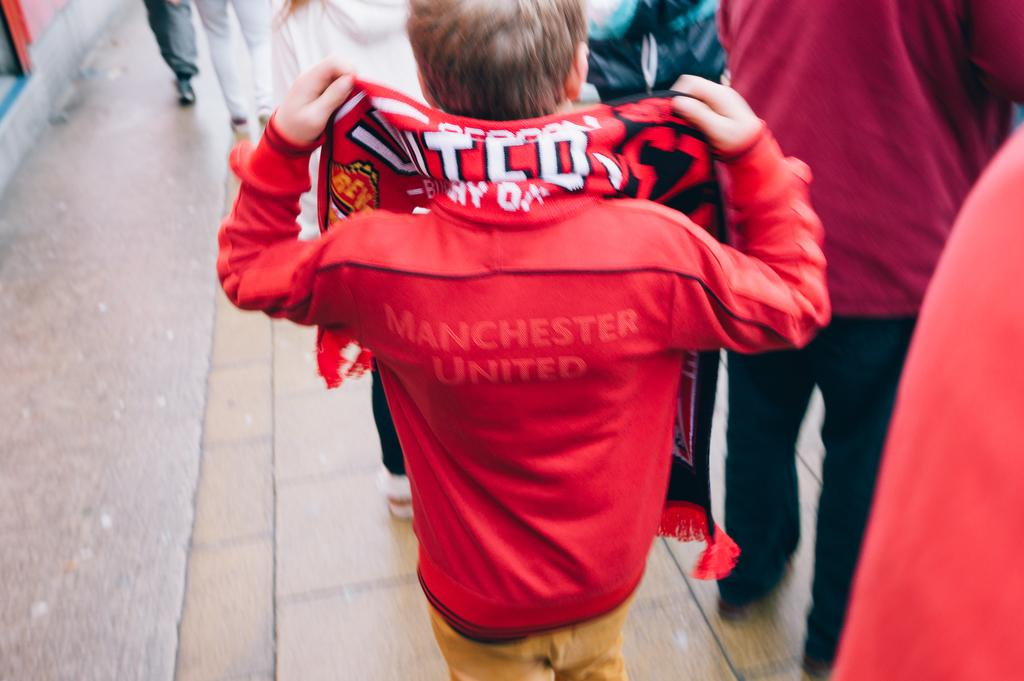Provide a one-sentence caption for the provided image. A boy sports a bright red jacket with the words MANCHESTER UNITED barely visible on it. 